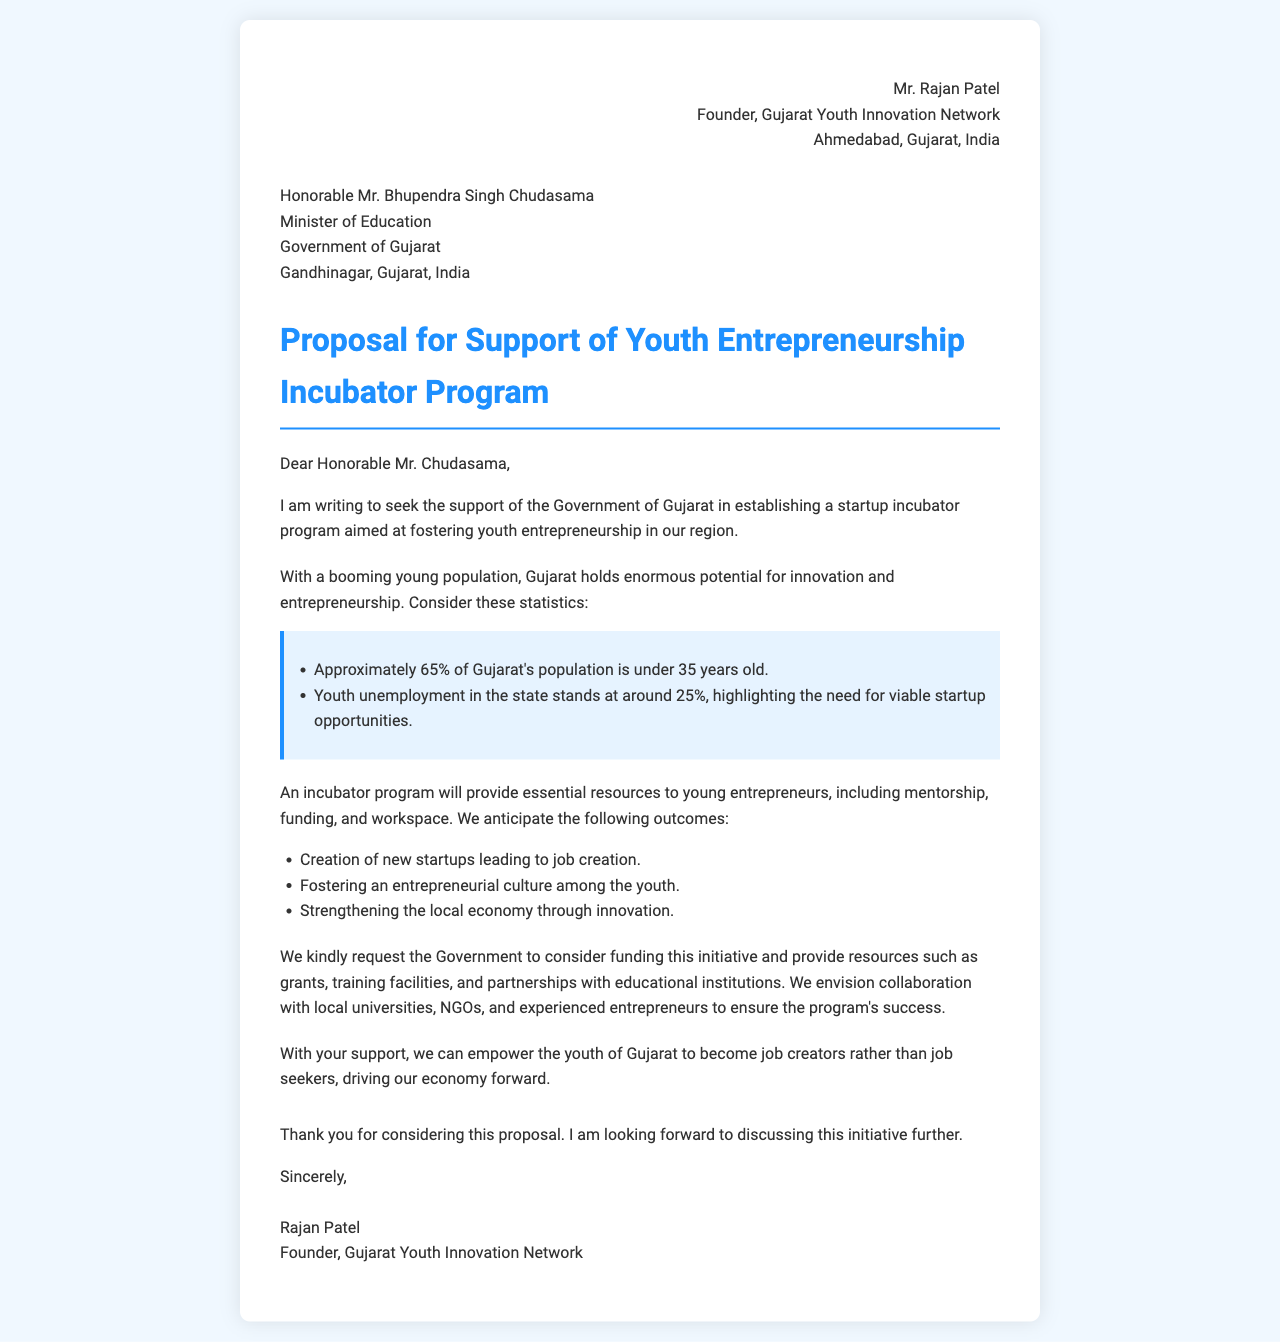What is the age demographic mentioned in the proposal? The proposal states that approximately 65% of Gujarat's population is under 35 years old.
Answer: 65% What is the youth unemployment rate in Gujarat? The letter mentions that youth unemployment in the state stands at around 25%.
Answer: 25% Who is the recipient of the letter? The letter is addressed to Honorable Mr. Bhupendra Singh Chudasama, Minister of Education.
Answer: Mr. Bhupendra Singh Chudasama What key outcomes are anticipated from the incubator program? The document lists several anticipated outcomes, including job creation, fostering an entrepreneurial culture, and strengthening the local economy.
Answer: Job creation What support is being requested from the government? The proposal requests funding, grants, training facilities, and partnerships with educational institutions.
Answer: Funding What is the name of the organization proposing the incubator program? The founder represents the Gujarat Youth Innovation Network.
Answer: Gujarat Youth Innovation Network What does the proposal aim to empower the youth to do? The proposal aims to empower youth to become job creators rather than job seekers.
Answer: Job creators What is the primary focus of the proposed incubator program? The primary focus is to foster youth entrepreneurship.
Answer: Youth entrepreneurship 